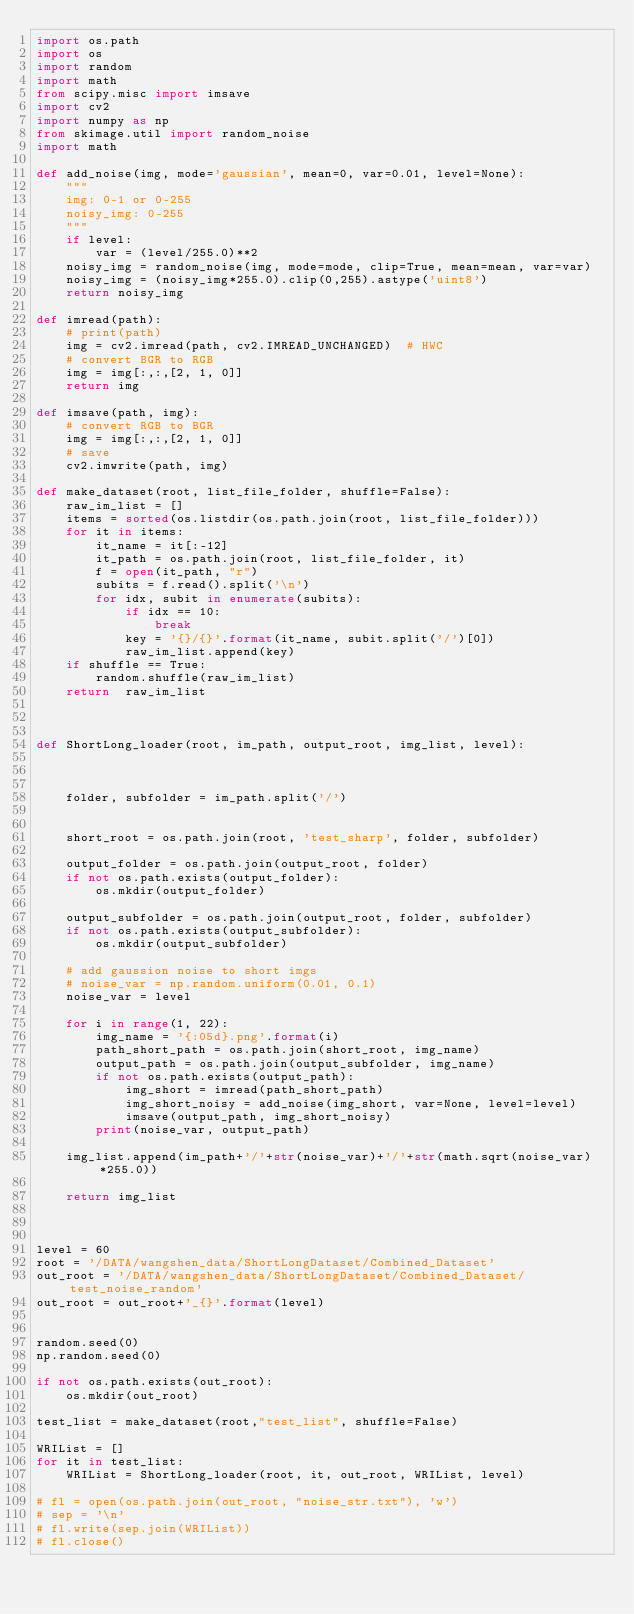Convert code to text. <code><loc_0><loc_0><loc_500><loc_500><_Python_>import os.path
import os
import random
import math
from scipy.misc import imsave
import cv2
import numpy as np
from skimage.util import random_noise
import math

def add_noise(img, mode='gaussian', mean=0, var=0.01, level=None):
    """
    img: 0-1 or 0-255
    noisy_img: 0-255
    """
    if level:
        var = (level/255.0)**2
    noisy_img = random_noise(img, mode=mode, clip=True, mean=mean, var=var)
    noisy_img = (noisy_img*255.0).clip(0,255).astype('uint8')
    return noisy_img

def imread(path):
    # print(path)
    img = cv2.imread(path, cv2.IMREAD_UNCHANGED)  # HWC
    # convert BGR to RGB
    img = img[:,:,[2, 1, 0]]
    return img

def imsave(path, img):
    # convert RGB to BGR
    img = img[:,:,[2, 1, 0]]
    # save
    cv2.imwrite(path, img)

def make_dataset(root, list_file_folder, shuffle=False):
    raw_im_list = []
    items = sorted(os.listdir(os.path.join(root, list_file_folder)))
    for it in items:
        it_name = it[:-12]
        it_path = os.path.join(root, list_file_folder, it)
        f = open(it_path, "r")
        subits = f.read().split('\n')
        for idx, subit in enumerate(subits):
            if idx == 10:
                break
            key = '{}/{}'.format(it_name, subit.split('/')[0])
            raw_im_list.append(key)
    if shuffle == True:
        random.shuffle(raw_im_list)
    return  raw_im_list



def ShortLong_loader(root, im_path, output_root, img_list, level):

    

    folder, subfolder = im_path.split('/')


    short_root = os.path.join(root, 'test_sharp', folder, subfolder)

    output_folder = os.path.join(output_root, folder)
    if not os.path.exists(output_folder):
        os.mkdir(output_folder)
    
    output_subfolder = os.path.join(output_root, folder, subfolder)
    if not os.path.exists(output_subfolder):
        os.mkdir(output_subfolder)

    # add gaussion noise to short imgs
    # noise_var = np.random.uniform(0.01, 0.1)
    noise_var = level

    for i in range(1, 22):
        img_name = '{:05d}.png'.format(i)
        path_short_path = os.path.join(short_root, img_name)
        output_path = os.path.join(output_subfolder, img_name)
        if not os.path.exists(output_path):
            img_short = imread(path_short_path)
            img_short_noisy = add_noise(img_short, var=None, level=level)
            imsave(output_path, img_short_noisy)
        print(noise_var, output_path)

    img_list.append(im_path+'/'+str(noise_var)+'/'+str(math.sqrt(noise_var)*255.0))

    return img_list

    

level = 60
root = '/DATA/wangshen_data/ShortLongDataset/Combined_Dataset'
out_root = '/DATA/wangshen_data/ShortLongDataset/Combined_Dataset/test_noise_random'
out_root = out_root+'_{}'.format(level)


random.seed(0)
np.random.seed(0)

if not os.path.exists(out_root):
    os.mkdir(out_root)

test_list = make_dataset(root,"test_list", shuffle=False)

WRIList = []
for it in test_list:
    WRIList = ShortLong_loader(root, it, out_root, WRIList, level)

# fl = open(os.path.join(out_root, "noise_str.txt"), 'w')
# sep = '\n'
# fl.write(sep.join(WRIList))
# fl.close()
</code> 